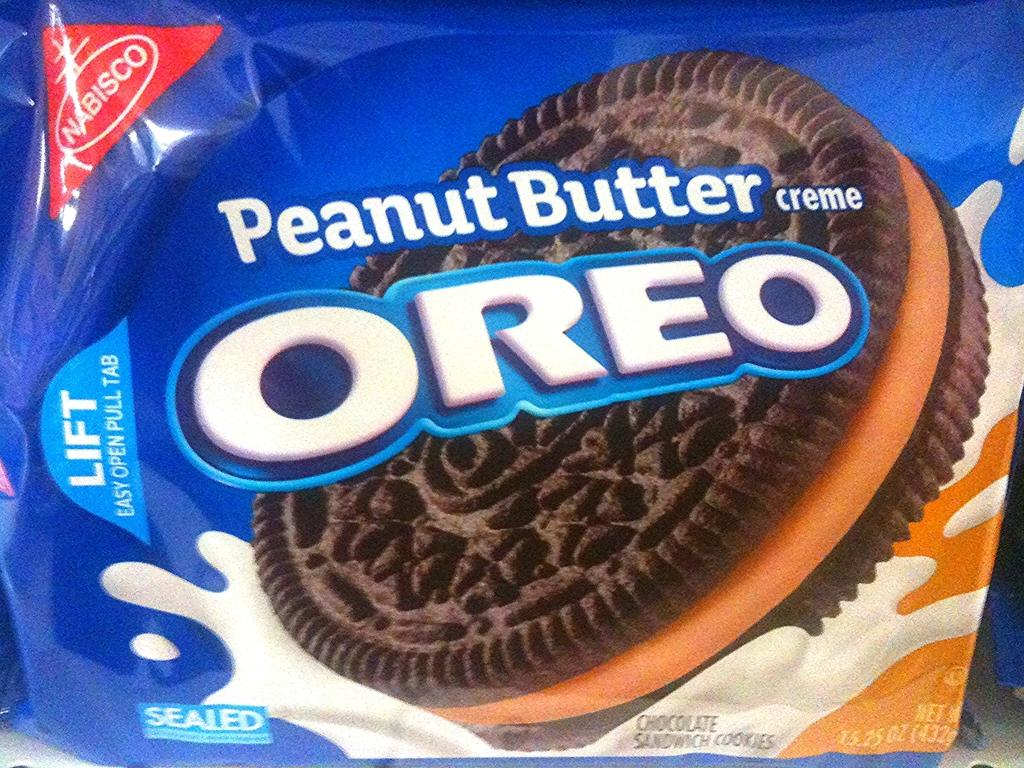What color is the cover that is visible in the image? The cover in the image is blue. What is written or printed on the blue cover? The blue cover has text on it. What image can be seen on the blue cover? There is a biscuit image on the blue cover. What type of fear does the rat on the blue cover experience in the image? There is no rat present in the image; it only features a blue cover with text and a biscuit image. 